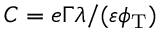Convert formula to latex. <formula><loc_0><loc_0><loc_500><loc_500>C = e \Gamma \lambda / ( \varepsilon \phi _ { T } )</formula> 